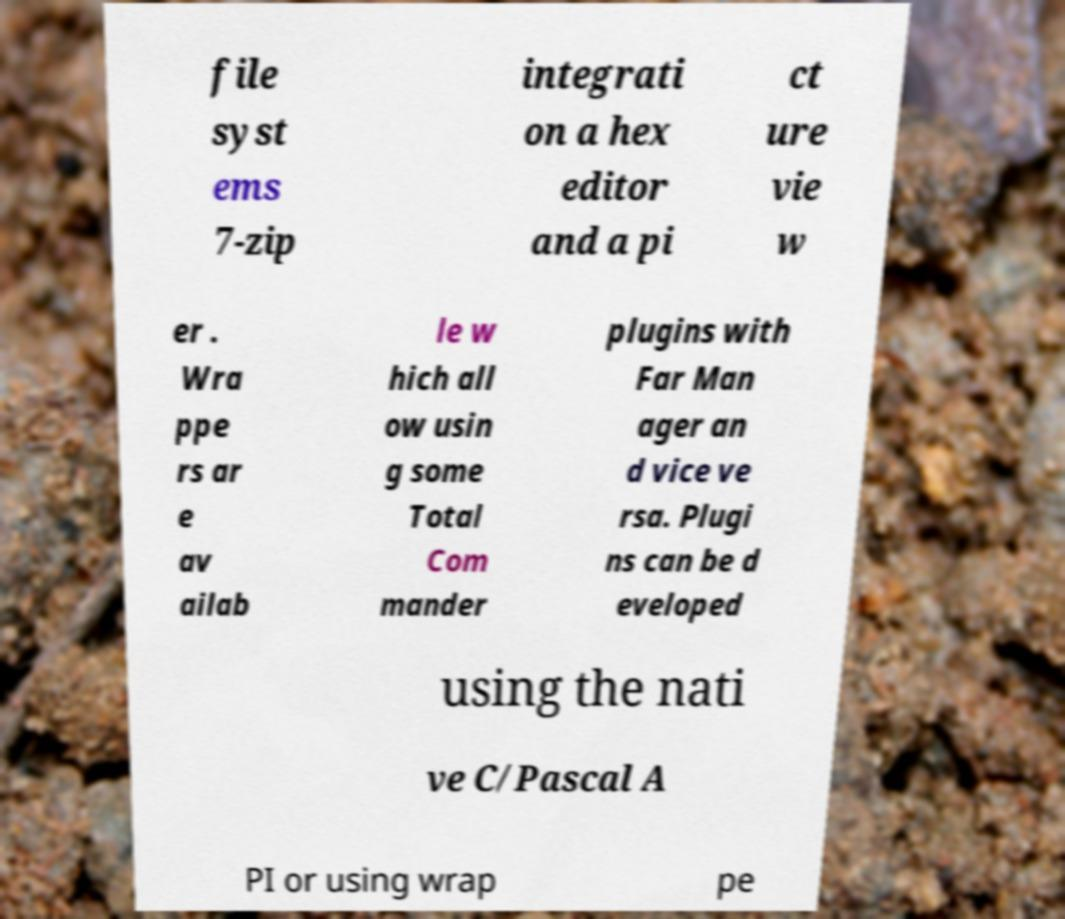Can you accurately transcribe the text from the provided image for me? file syst ems 7-zip integrati on a hex editor and a pi ct ure vie w er . Wra ppe rs ar e av ailab le w hich all ow usin g some Total Com mander plugins with Far Man ager an d vice ve rsa. Plugi ns can be d eveloped using the nati ve C/Pascal A PI or using wrap pe 